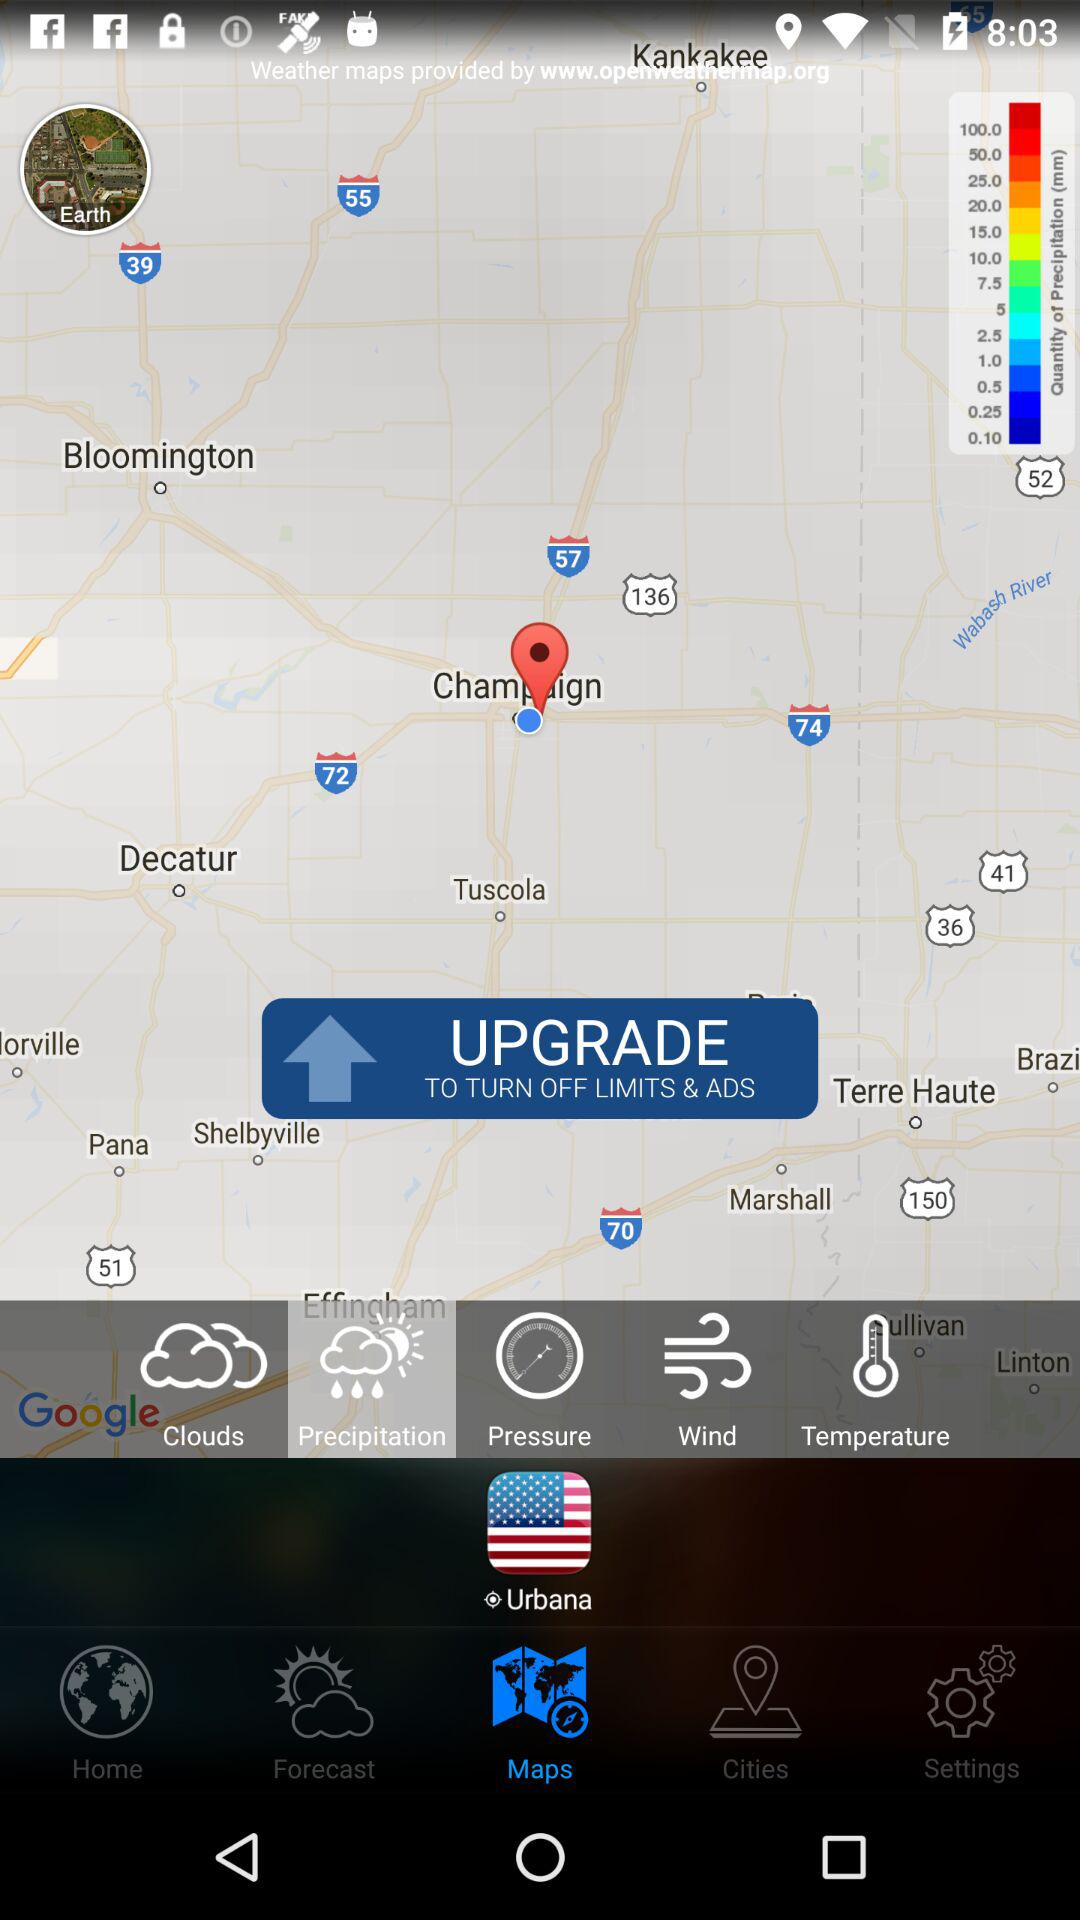Which tab is selected? The selected tabs are "Maps" and "Precipitation". 